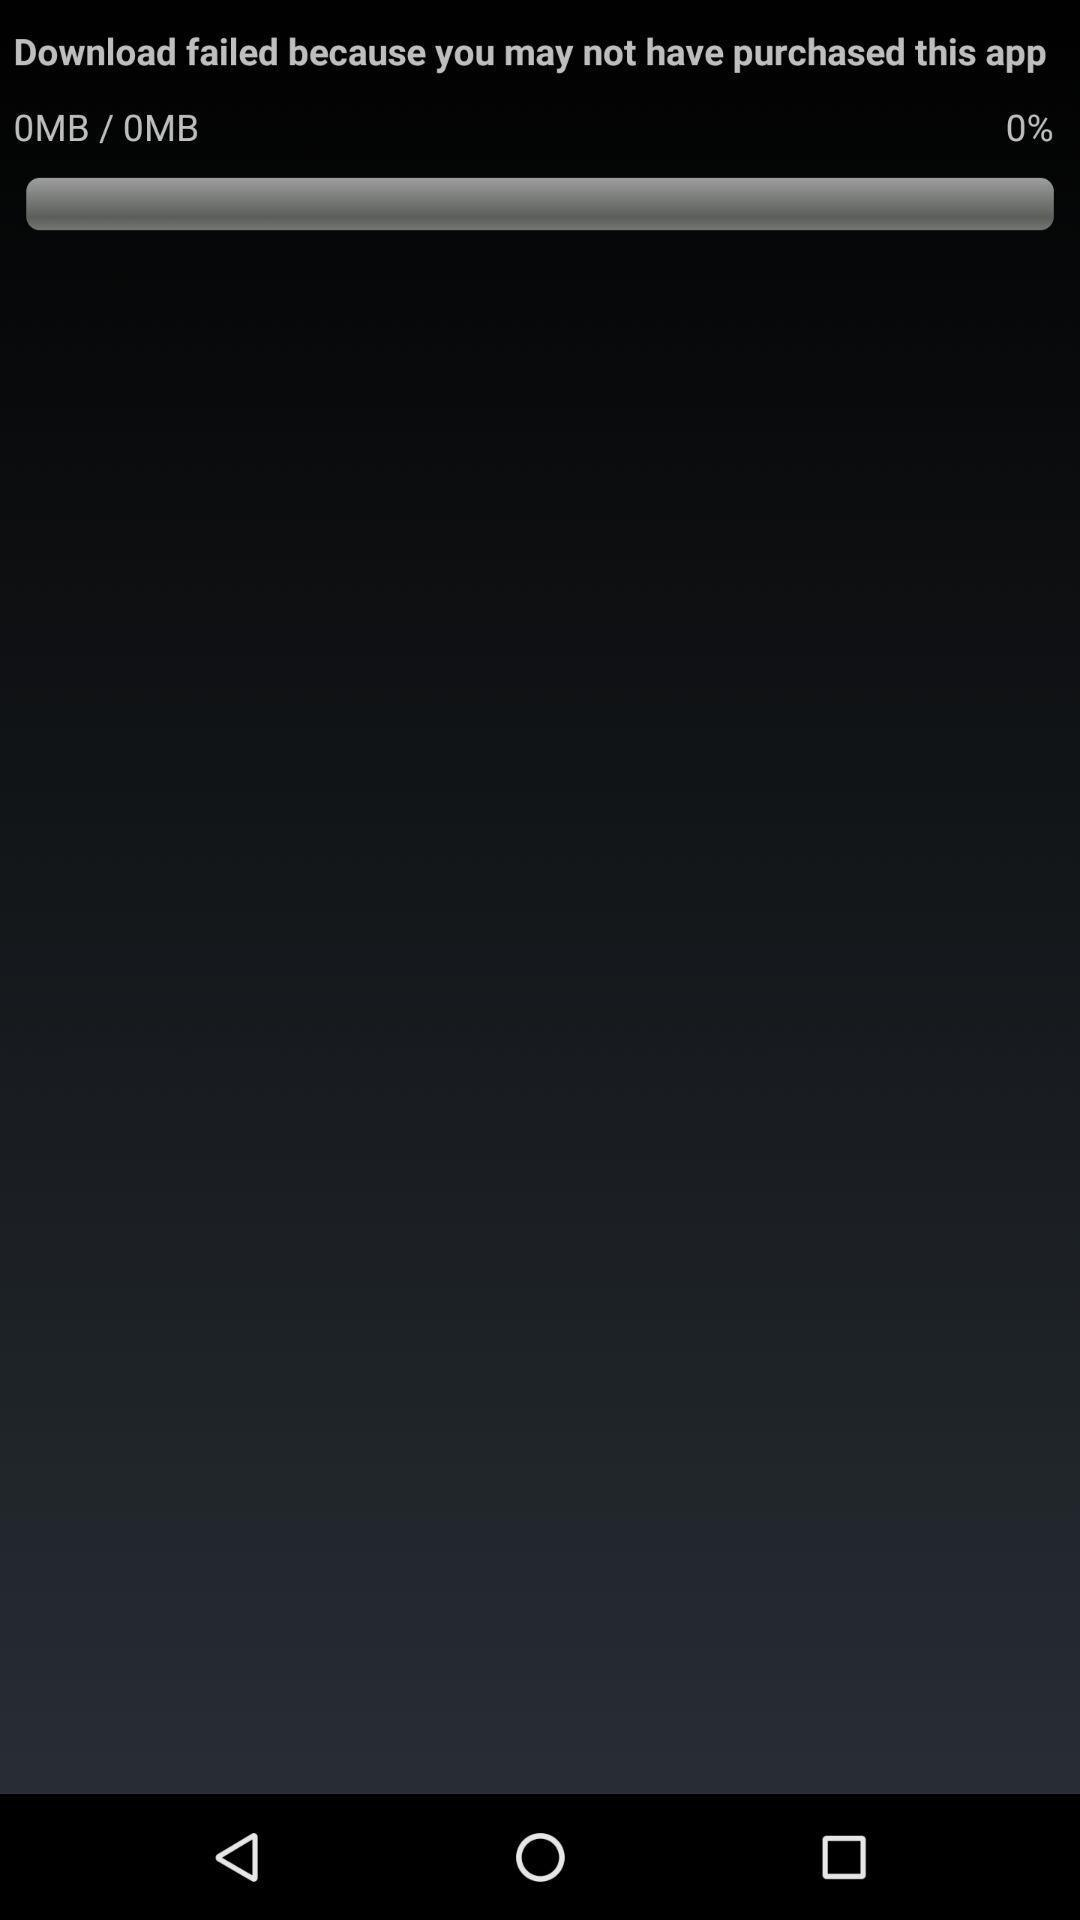How much progress has been made towards downloading the app?
Answer the question using a single word or phrase. 0% 